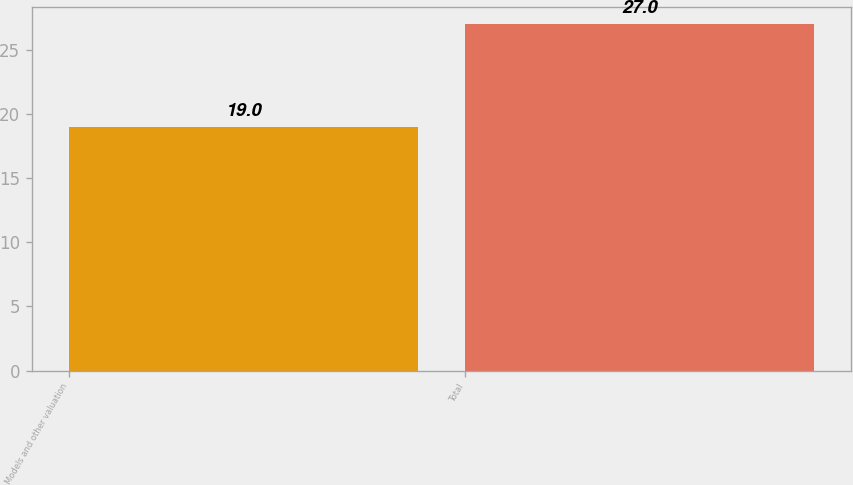Convert chart. <chart><loc_0><loc_0><loc_500><loc_500><bar_chart><fcel>Models and other valuation<fcel>Total<nl><fcel>19<fcel>27<nl></chart> 